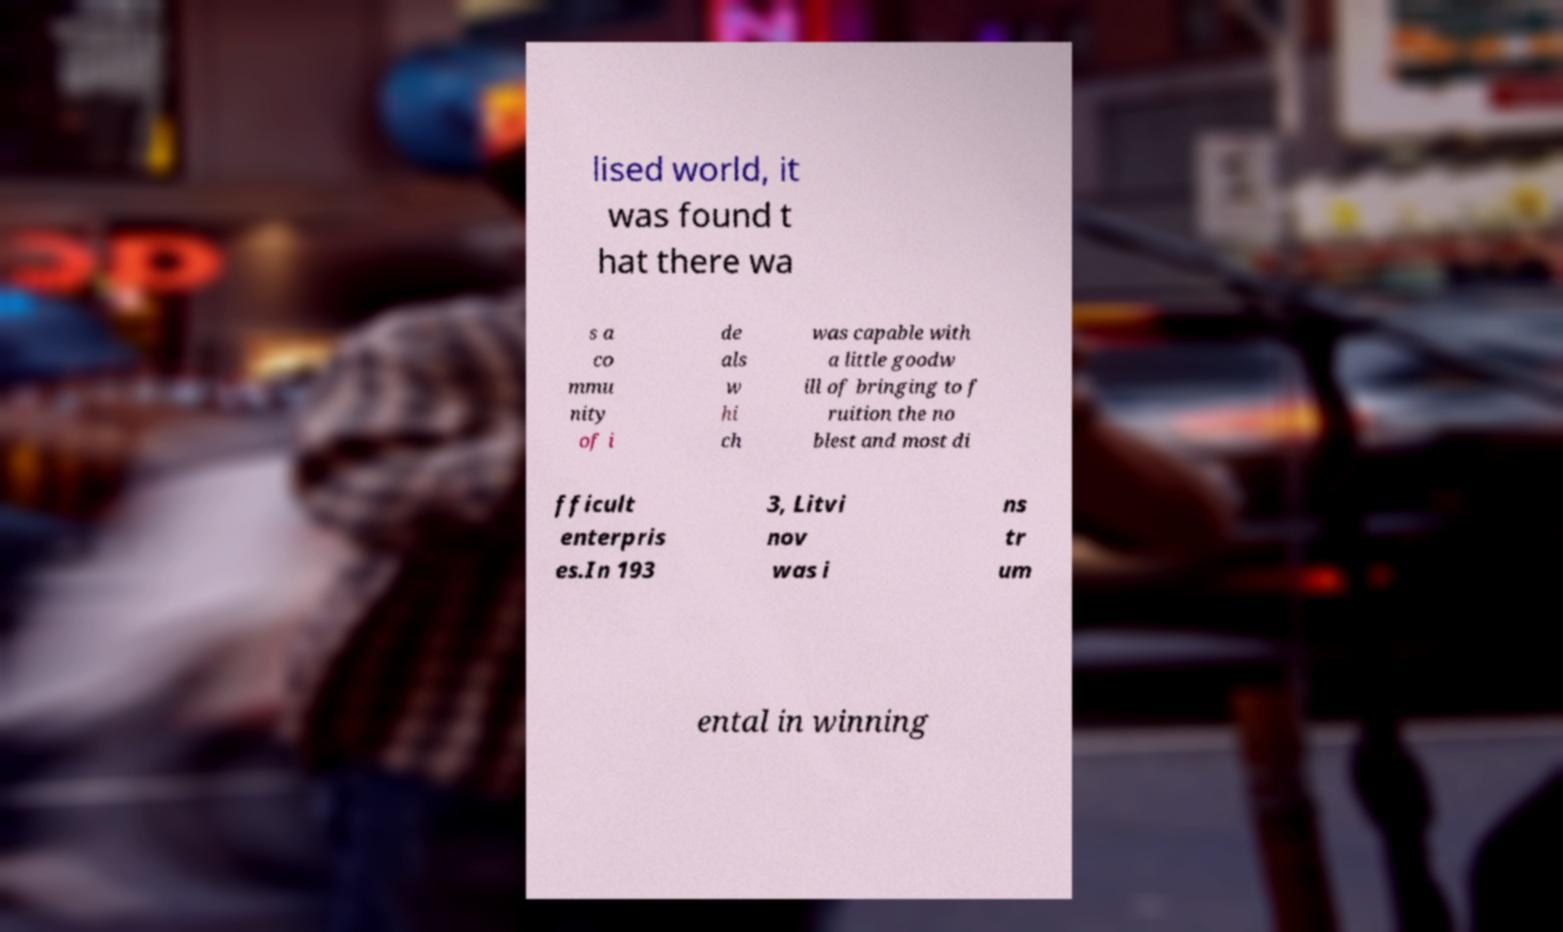What messages or text are displayed in this image? I need them in a readable, typed format. lised world, it was found t hat there wa s a co mmu nity of i de als w hi ch was capable with a little goodw ill of bringing to f ruition the no blest and most di fficult enterpris es.In 193 3, Litvi nov was i ns tr um ental in winning 